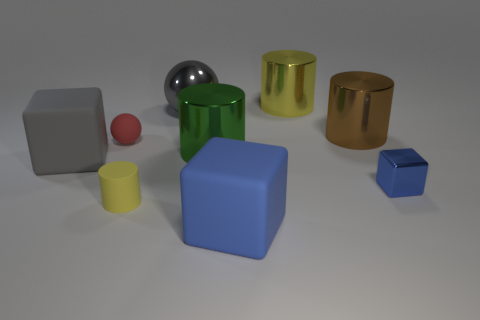Subtract all blue cylinders. How many blue cubes are left? 2 Subtract all big matte blocks. How many blocks are left? 1 Add 1 small blue cubes. How many objects exist? 10 Subtract all green cylinders. How many cylinders are left? 3 Subtract 1 cylinders. How many cylinders are left? 3 Subtract all blocks. How many objects are left? 6 Add 3 small metallic cylinders. How many small metallic cylinders exist? 3 Subtract 0 red cylinders. How many objects are left? 9 Subtract all brown cylinders. Subtract all green cubes. How many cylinders are left? 3 Subtract all large yellow metal cylinders. Subtract all gray cubes. How many objects are left? 7 